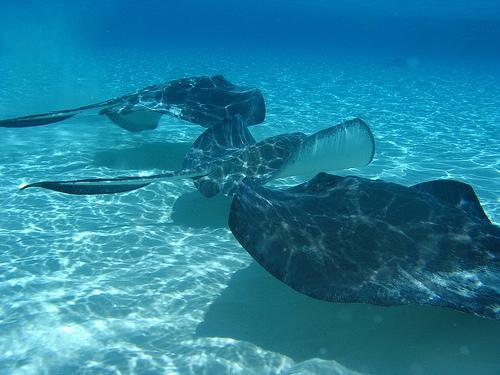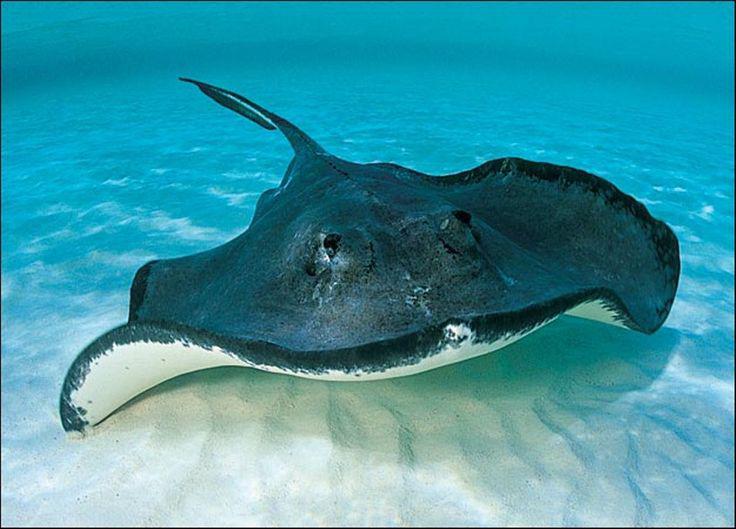The first image is the image on the left, the second image is the image on the right. For the images shown, is this caption "At least one of the images displays more than one of the manta rays, who seem to swim in larger groups regularly." true? Answer yes or no. Yes. The first image is the image on the left, the second image is the image on the right. Assess this claim about the two images: "No image contains more than three stingray in the foreground, and no image contains other types of fish.". Correct or not? Answer yes or no. Yes. 